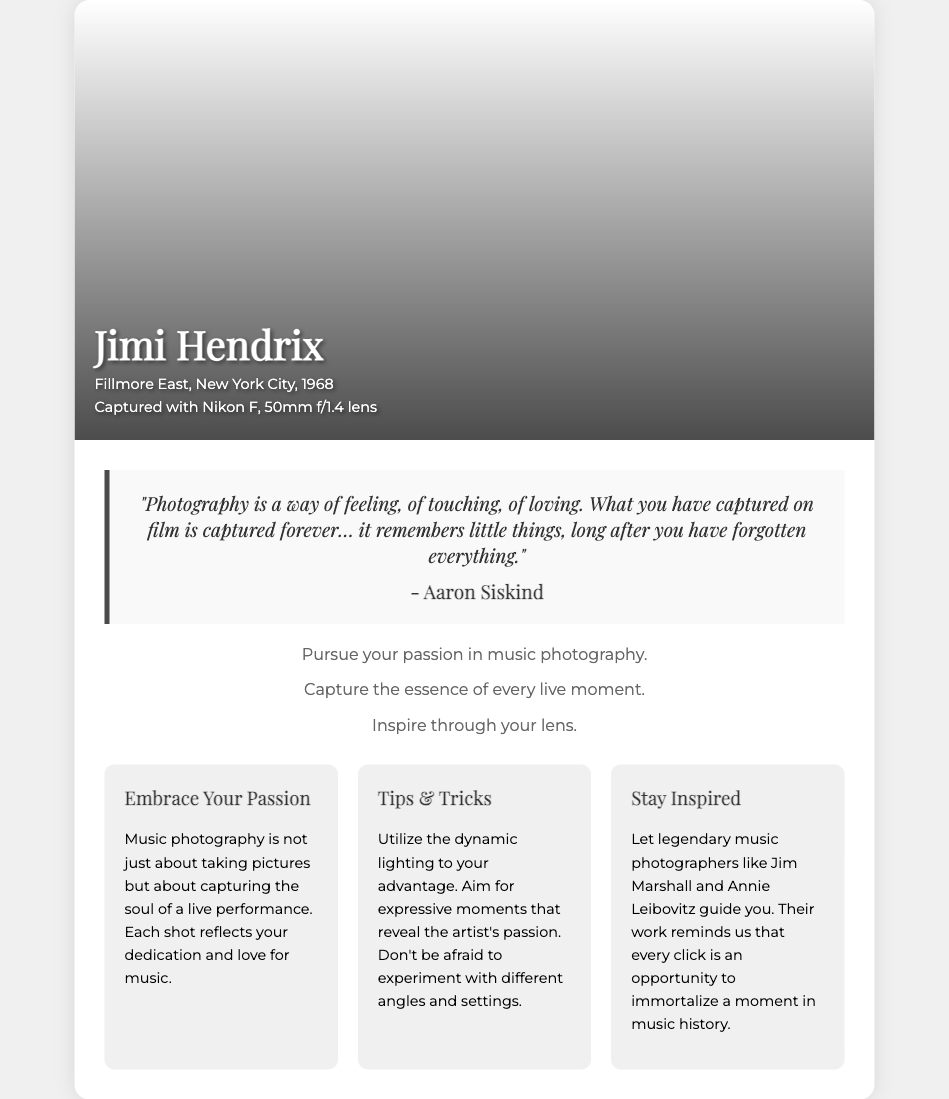What is the name of the artist featured in the cover photo? The document includes the name of the artist, which is prominently displayed on the card in bold lettering.
Answer: Jimi Hendrix What is the location of the performance captured in the photo? The location is specified directly beneath the artist's name, indicating where the performance took place.
Answer: Fillmore East, New York City What year was the photo taken? The year is mentioned below the location of the performance, indicating the time of capture.
Answer: 1968 What camera was used to take the photograph? The document specifies the camera model used for the photo within the details of the cover photo.
Answer: Nikon F What is the quote attributed to Aaron Siskind about photography? The quote is highlighted in the document and conveys a thoughtful message about the nature of photography, specifying who it is attributed to.
Answer: "Photography is a way of feeling, of touching, of loving. What you have captured on film is captured forever… it remembers little things, long after you have forgotten everything." What is the main theme of the motivational card? The overall message of the card is stated clearly in the subtext of the content section, emphasizing the significance of pursuing hobbies.
Answer: Pursue your passion in music photography What are two key tips for music photography mentioned in the document? The document lists practical advice for photographers who aim to capture music moments, focusing on the use of dynamic lighting and angles.
Answer: Utilize dynamic lighting, experiment with angles Who are two legendary photographers mentioned as inspirations? The names of these prominent photographers are cited in the text, serving as role models for aspiring music photographers.
Answer: Jim Marshall, Annie Leibovitz What does each section in the motivational content aim to convey? The sections aim to provide insights related to music photography, including encouragement, tips, and inspiration for photographers.
Answer: Embrace Your Passion, Tips & Tricks, Stay Inspired 